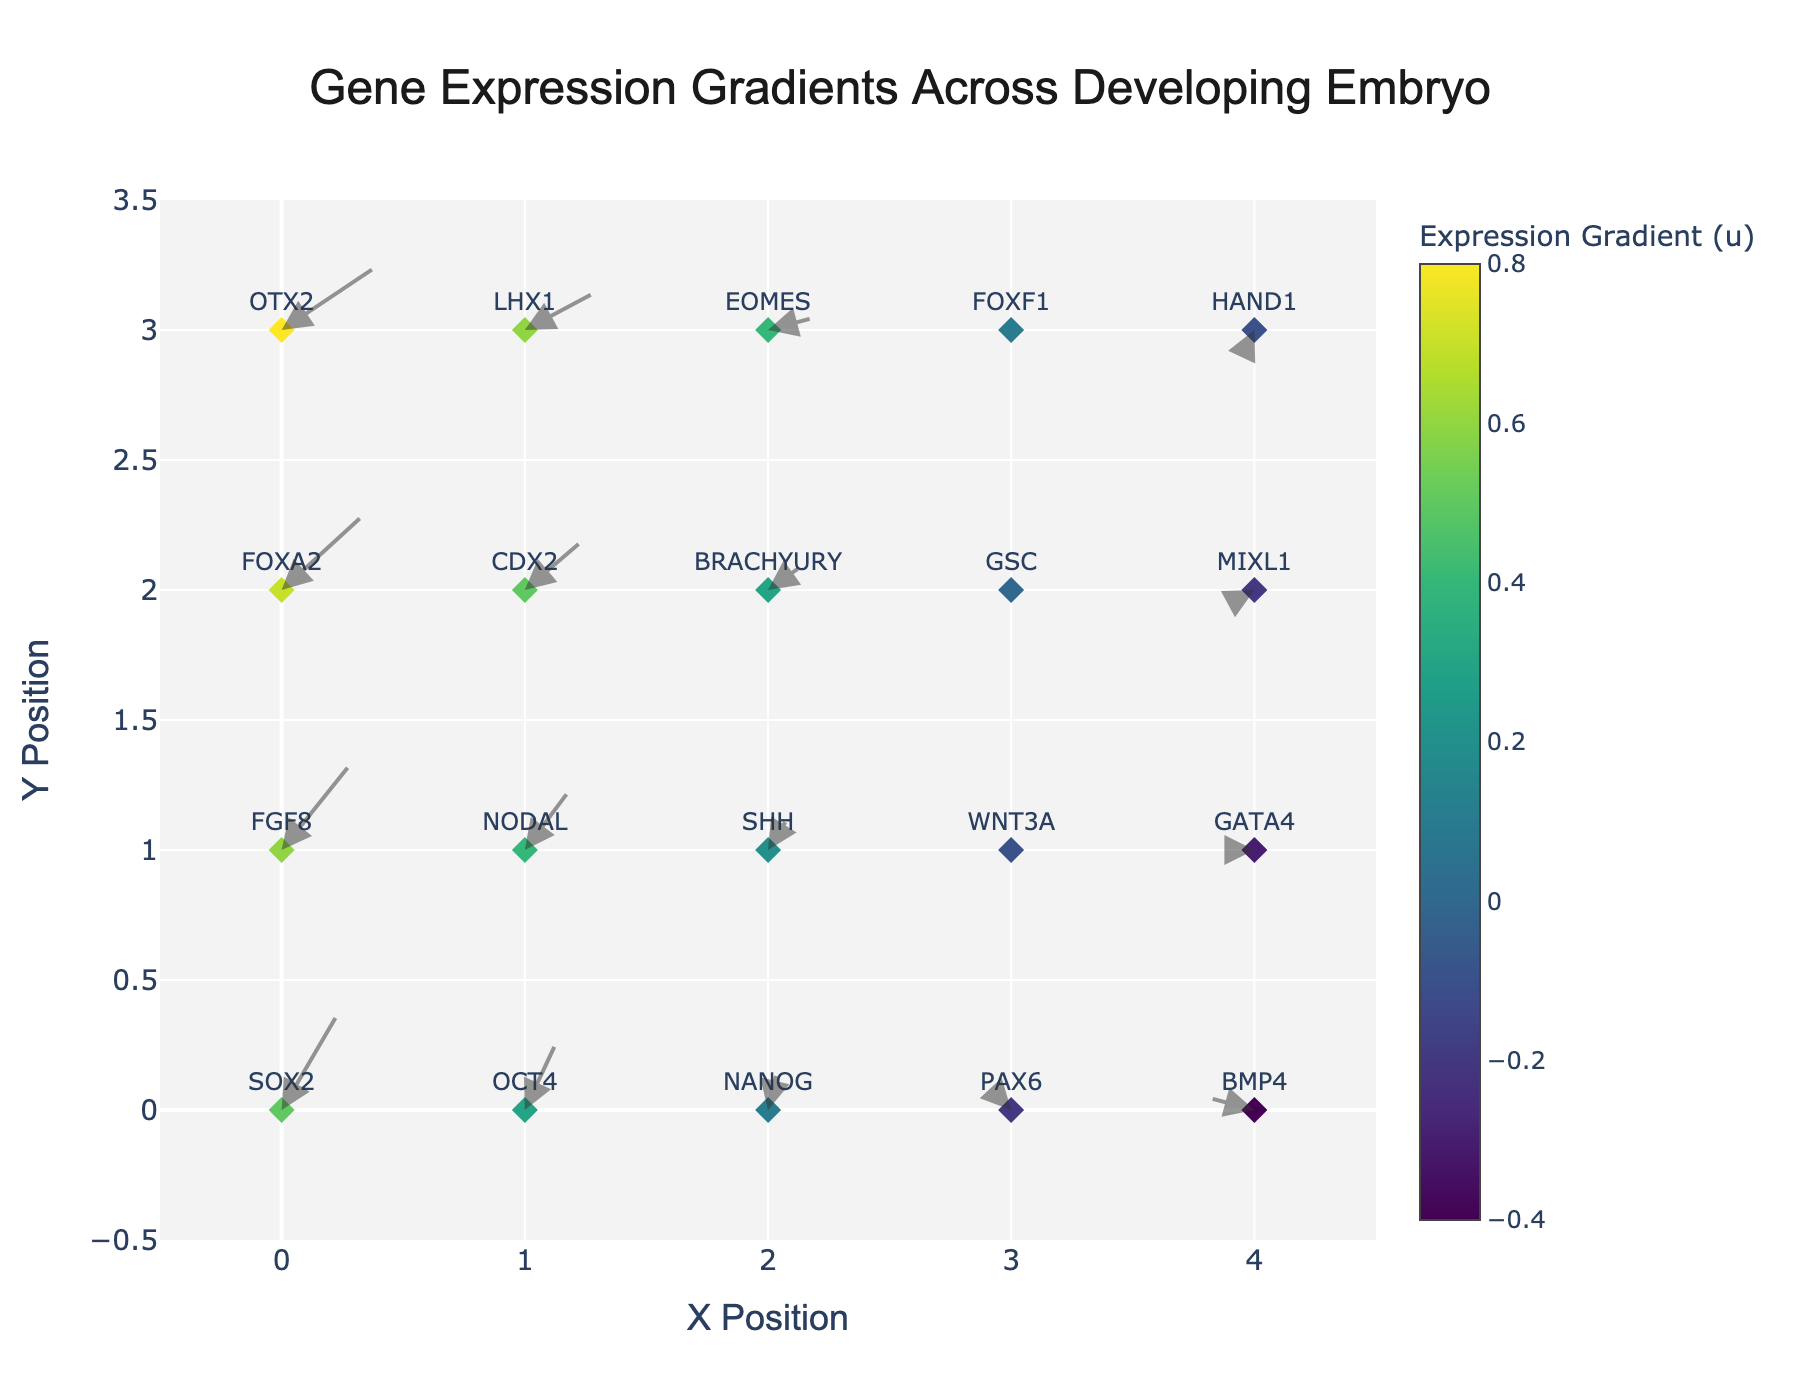How many genes are located in the y=2 row? By inspecting the figure, we see markers for genes FOXA2, CDX2, BRACHYURY, GSC, and MIXL1 along y=2. This shows there are 5 genes in that row.
Answer: 5 Which gene shows the highest vertical gradient (v) value? Among the genes, we need to look at the arrows with the largest vertical component, which is indicated by the v value. FOXA2 at (0,2) shows the highest vertical gradient with a v value of 0.6.
Answer: FOXA2 What is the color of the marker representing the gene with the most negative horizontal gradient (u)? The gene with the most negative horizontal gradient (u=-0.4) is BMP4 at (4,0). Referring to the color bar for scale, it would be in the range represented by darker shades of the used colormap.
Answer: Dark shade (seen visually on the plot) Compare the horizontal gradient (u) values of OTX2 and GSC and determine which is greater. From the plot, OTX2 at (0,3) has a u value of 0.8 and GSC at (3,2) has a u value of 0. Both values are visible on the plot. Hence, 0.8 > 0.
Answer: OTX2 has a greater horizontal gradient What is the horizontal distance covered by the arrow for the gene NANOG? NANOG is located at (2,0) with a u value of 0.1. The horizontal distance is calculated as 0.1 * scale factor (0.5) = 0.05.
Answer: 0.05 Which gene shows no movement in the quiver plot? The gene GSC at (3,2) has arrows set at 0 for both u and v values, indicating no movement.
Answer: GSC What is the X position range for the gene expressions shown in the plot? Based on the figure, the x-axis begins at -0.5 and ends at 4.5. These limits are shown as the range on the x-axis of the plot.
Answer: -0.5 to 4.5 In which direction do the arrows for HAND1 point? HAND1 is located at (4,3) with a u value of -0.1 and a v value of -0.2. This means the arrow points to the left and down.
Answer: Left and down What is the average horizontal gradient (u) of the genes located at y=0? The y=0 row contains SOX2, OCT4, NANOG, PAX6, and BMP4 with u values of 0.5, 0.3, 0.1, -0.2, and -0.4 respectively. Their average is (0.5 + 0.3 + 0.1 - 0.2 - 0.4) / 5 = 0.06.
Answer: 0.06 Which gene at y=1 has the smallest vertical gradient (v) value? Looking at the y=1 row, genes and their v values are FGF8 (0.7), NODAL (0.5), SHH (0.3), WNT3A (0.1), and GATA4 (0). Among these, GATA4 has the smallest vertical gradient.
Answer: GATA4 